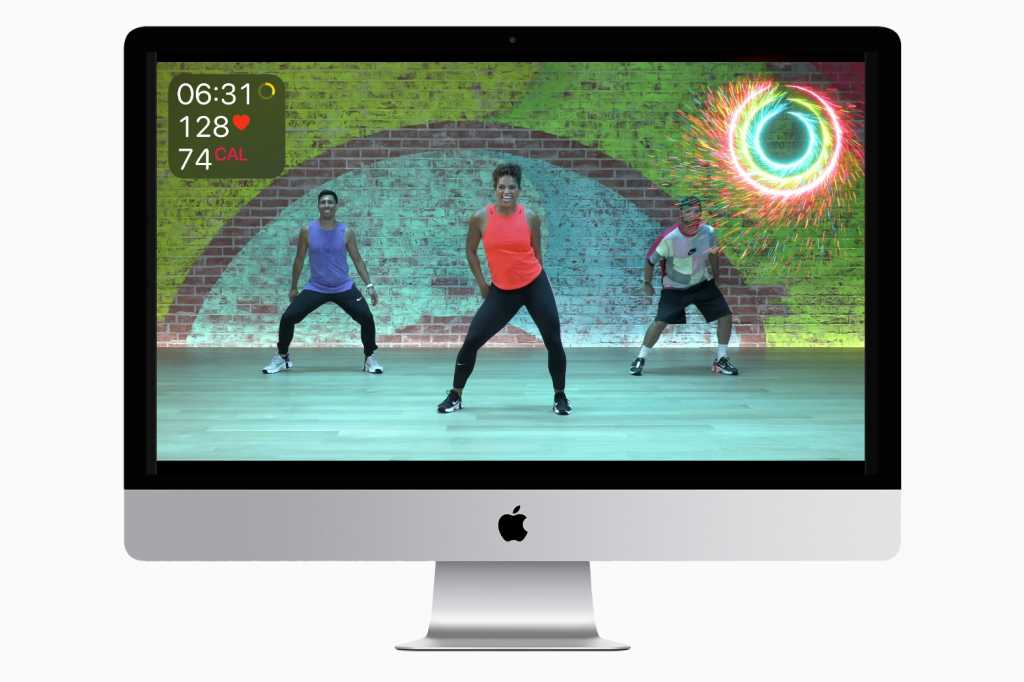What does the vibrant circular graphic on the right side of the screen represent? The vibrant circular graphic on the right side of the screen likely represents a visual cue related to the intensity or progress of the workout. Such graphics are often used in fitness applications to make the workout experience more engaging and to provide immediate visual feedback on performance metrics or milestones achieved during the session. How might this software enhance the user's fitness experience? This software can enhance the user's fitness experience by providing real-time feedback on essential fitness metrics such as time elapsed, heart rate, and calories burned. The dynamic and colorful interface can help maintain user motivation and engagement by making the workout sessions visually stimulating. Additionally, the presence of graphical elements like the vibrant circular graphic may serve as progress indicators, helping users track their performance and stay motivated to reach their fitness goals. By monitoring these metrics, the software can also suggest personalized workout adjustments to optimize the effectiveness of the training sessions. 